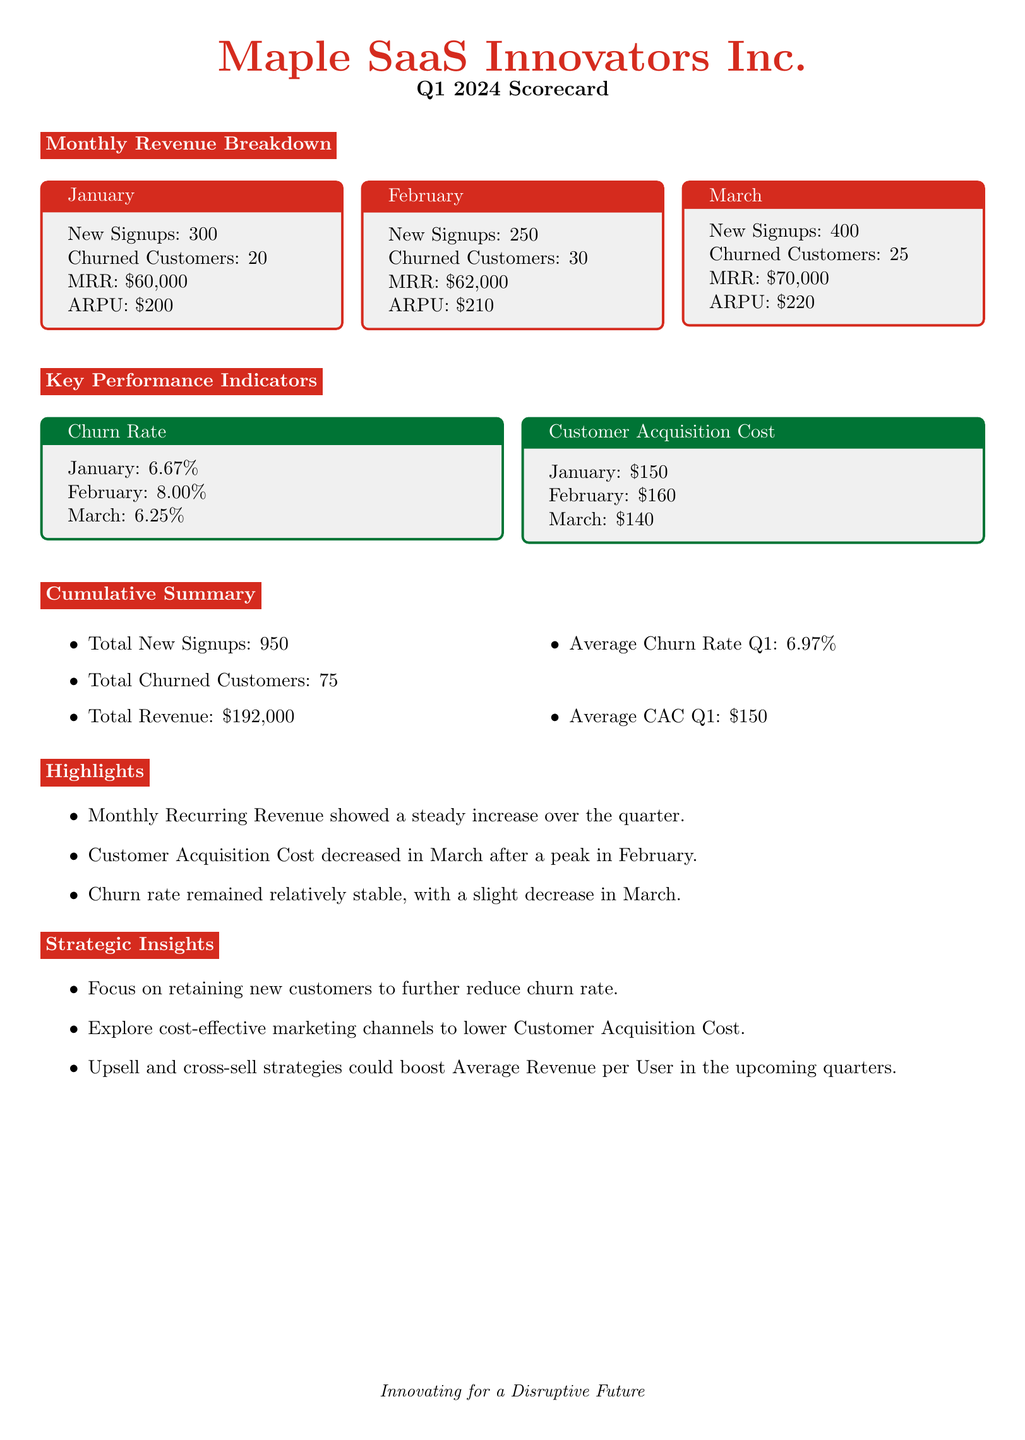What was the Monthly Recurring Revenue in January? The Monthly Recurring Revenue (MRR) in January is listed in the document.
Answer: $60,000 What is the churn rate for February? The churn rate for February can be directly retrieved from the Key Performance Indicators section of the document.
Answer: 8.00% How many total new signups were there in Q1? The total new signups can be found in the Cumulative Summary section of the document.
Answer: 950 What was the average churn rate for Q1? The average churn rate is provided in the Cumulative Summary and is calculated from the monthly churn rates.
Answer: 6.97% What was the Customer Acquisition Cost in March? The Customer Acquisition Cost for March is detailed in the Key Performance Indicators section of the document.
Answer: $140 Which month had the highest churn rate? By comparing the churn rates presented for each month, we can determine that February had the highest rate.
Answer: February What total revenue was generated in Q1? The document summarizes total revenue in the Cumulative Summary section, where it is stated directly.
Answer: $192,000 What trend is observed in Customer Acquisition Cost from January to March? The document notes changes in Customer Acquisition Cost over the months, indicating a specific trend.
Answer: Decreased What is the Average Revenue per User in March? The Average Revenue per User (ARPU) for March is provided in the Monthly Revenue Breakdown section.
Answer: $220 